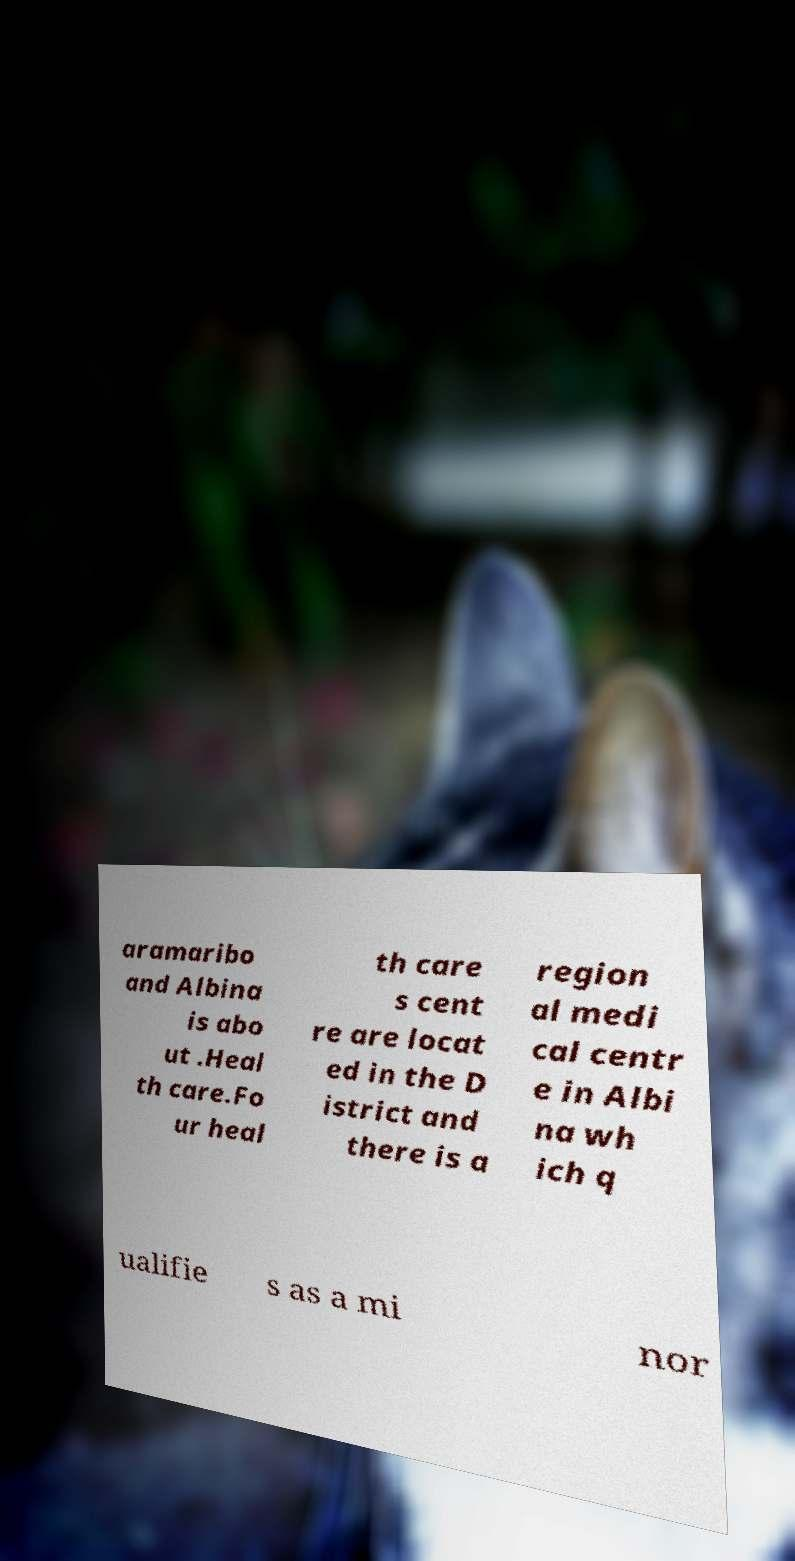Please read and relay the text visible in this image. What does it say? aramaribo and Albina is abo ut .Heal th care.Fo ur heal th care s cent re are locat ed in the D istrict and there is a region al medi cal centr e in Albi na wh ich q ualifie s as a mi nor 